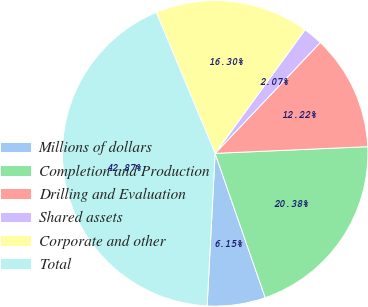<chart> <loc_0><loc_0><loc_500><loc_500><pie_chart><fcel>Millions of dollars<fcel>Completion and Production<fcel>Drilling and Evaluation<fcel>Shared assets<fcel>Corporate and other<fcel>Total<nl><fcel>6.15%<fcel>20.38%<fcel>12.22%<fcel>2.07%<fcel>16.3%<fcel>42.87%<nl></chart> 